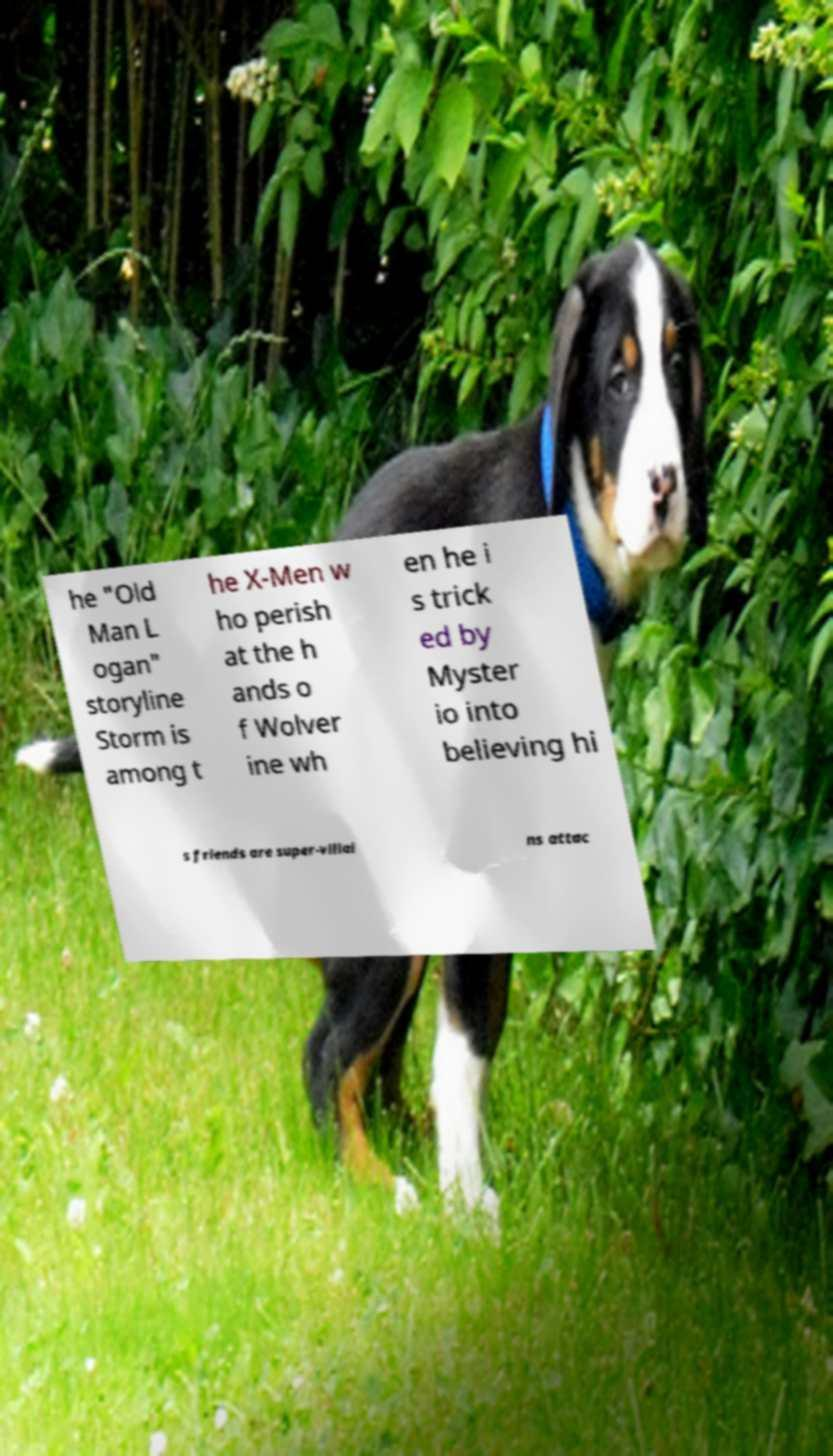There's text embedded in this image that I need extracted. Can you transcribe it verbatim? he "Old Man L ogan" storyline Storm is among t he X-Men w ho perish at the h ands o f Wolver ine wh en he i s trick ed by Myster io into believing hi s friends are super-villai ns attac 